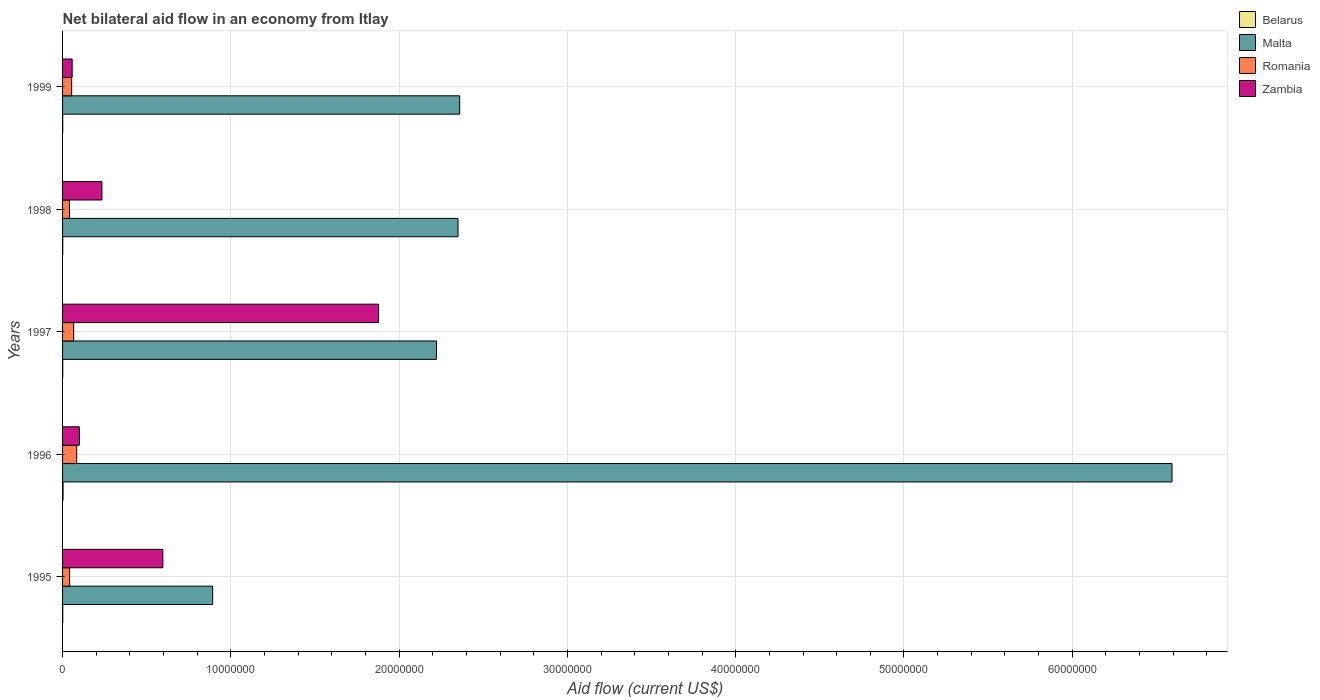How many bars are there on the 1st tick from the top?
Your answer should be very brief. 4. How many bars are there on the 3rd tick from the bottom?
Make the answer very short. 4. What is the label of the 3rd group of bars from the top?
Provide a succinct answer. 1997. What is the net bilateral aid flow in Romania in 1998?
Your answer should be very brief. 4.10e+05. Across all years, what is the maximum net bilateral aid flow in Belarus?
Your answer should be compact. 3.00e+04. Across all years, what is the minimum net bilateral aid flow in Malta?
Offer a terse response. 8.92e+06. In which year was the net bilateral aid flow in Malta maximum?
Make the answer very short. 1996. In which year was the net bilateral aid flow in Zambia minimum?
Your response must be concise. 1999. What is the total net bilateral aid flow in Romania in the graph?
Offer a very short reply. 2.87e+06. What is the difference between the net bilateral aid flow in Belarus in 1998 and the net bilateral aid flow in Malta in 1999?
Your response must be concise. -2.36e+07. What is the average net bilateral aid flow in Belarus per year?
Ensure brevity in your answer.  1.40e+04. In the year 1998, what is the difference between the net bilateral aid flow in Belarus and net bilateral aid flow in Zambia?
Give a very brief answer. -2.33e+06. What is the ratio of the net bilateral aid flow in Romania in 1997 to that in 1999?
Offer a terse response. 1.22. What is the difference between the highest and the second highest net bilateral aid flow in Belarus?
Keep it short and to the point. 2.00e+04. What is the difference between the highest and the lowest net bilateral aid flow in Zambia?
Provide a short and direct response. 1.82e+07. Is the sum of the net bilateral aid flow in Malta in 1995 and 1997 greater than the maximum net bilateral aid flow in Belarus across all years?
Offer a very short reply. Yes. Is it the case that in every year, the sum of the net bilateral aid flow in Malta and net bilateral aid flow in Zambia is greater than the sum of net bilateral aid flow in Romania and net bilateral aid flow in Belarus?
Keep it short and to the point. Yes. What does the 3rd bar from the top in 1997 represents?
Provide a succinct answer. Malta. What does the 4th bar from the bottom in 1997 represents?
Offer a very short reply. Zambia. Does the graph contain any zero values?
Your answer should be compact. No. Does the graph contain grids?
Provide a succinct answer. Yes. How many legend labels are there?
Provide a succinct answer. 4. What is the title of the graph?
Your answer should be compact. Net bilateral aid flow in an economy from Itlay. Does "South Sudan" appear as one of the legend labels in the graph?
Your answer should be very brief. No. What is the Aid flow (current US$) in Belarus in 1995?
Offer a terse response. 10000. What is the Aid flow (current US$) in Malta in 1995?
Your answer should be very brief. 8.92e+06. What is the Aid flow (current US$) of Zambia in 1995?
Your response must be concise. 5.96e+06. What is the Aid flow (current US$) of Belarus in 1996?
Your response must be concise. 3.00e+04. What is the Aid flow (current US$) in Malta in 1996?
Ensure brevity in your answer.  6.59e+07. What is the Aid flow (current US$) in Romania in 1996?
Your response must be concise. 8.40e+05. What is the Aid flow (current US$) in Belarus in 1997?
Your answer should be compact. 10000. What is the Aid flow (current US$) of Malta in 1997?
Give a very brief answer. 2.22e+07. What is the Aid flow (current US$) in Zambia in 1997?
Provide a short and direct response. 1.88e+07. What is the Aid flow (current US$) of Malta in 1998?
Offer a terse response. 2.35e+07. What is the Aid flow (current US$) of Zambia in 1998?
Offer a terse response. 2.34e+06. What is the Aid flow (current US$) in Malta in 1999?
Make the answer very short. 2.36e+07. What is the Aid flow (current US$) in Romania in 1999?
Your answer should be very brief. 5.40e+05. What is the Aid flow (current US$) in Zambia in 1999?
Make the answer very short. 5.70e+05. Across all years, what is the maximum Aid flow (current US$) of Malta?
Your answer should be compact. 6.59e+07. Across all years, what is the maximum Aid flow (current US$) of Romania?
Offer a very short reply. 8.40e+05. Across all years, what is the maximum Aid flow (current US$) in Zambia?
Provide a succinct answer. 1.88e+07. Across all years, what is the minimum Aid flow (current US$) in Belarus?
Your answer should be compact. 10000. Across all years, what is the minimum Aid flow (current US$) in Malta?
Your answer should be very brief. 8.92e+06. Across all years, what is the minimum Aid flow (current US$) of Romania?
Provide a short and direct response. 4.10e+05. Across all years, what is the minimum Aid flow (current US$) of Zambia?
Your answer should be compact. 5.70e+05. What is the total Aid flow (current US$) in Belarus in the graph?
Offer a very short reply. 7.00e+04. What is the total Aid flow (current US$) in Malta in the graph?
Make the answer very short. 1.44e+08. What is the total Aid flow (current US$) in Romania in the graph?
Keep it short and to the point. 2.87e+06. What is the total Aid flow (current US$) of Zambia in the graph?
Ensure brevity in your answer.  2.86e+07. What is the difference between the Aid flow (current US$) of Malta in 1995 and that in 1996?
Give a very brief answer. -5.70e+07. What is the difference between the Aid flow (current US$) in Romania in 1995 and that in 1996?
Your response must be concise. -4.20e+05. What is the difference between the Aid flow (current US$) in Zambia in 1995 and that in 1996?
Your answer should be very brief. 4.96e+06. What is the difference between the Aid flow (current US$) of Malta in 1995 and that in 1997?
Ensure brevity in your answer.  -1.33e+07. What is the difference between the Aid flow (current US$) of Romania in 1995 and that in 1997?
Ensure brevity in your answer.  -2.40e+05. What is the difference between the Aid flow (current US$) of Zambia in 1995 and that in 1997?
Offer a very short reply. -1.28e+07. What is the difference between the Aid flow (current US$) of Belarus in 1995 and that in 1998?
Your answer should be very brief. 0. What is the difference between the Aid flow (current US$) in Malta in 1995 and that in 1998?
Your response must be concise. -1.46e+07. What is the difference between the Aid flow (current US$) of Romania in 1995 and that in 1998?
Give a very brief answer. 10000. What is the difference between the Aid flow (current US$) of Zambia in 1995 and that in 1998?
Keep it short and to the point. 3.62e+06. What is the difference between the Aid flow (current US$) in Belarus in 1995 and that in 1999?
Your answer should be compact. 0. What is the difference between the Aid flow (current US$) of Malta in 1995 and that in 1999?
Make the answer very short. -1.47e+07. What is the difference between the Aid flow (current US$) of Romania in 1995 and that in 1999?
Your answer should be very brief. -1.20e+05. What is the difference between the Aid flow (current US$) of Zambia in 1995 and that in 1999?
Make the answer very short. 5.39e+06. What is the difference between the Aid flow (current US$) in Belarus in 1996 and that in 1997?
Give a very brief answer. 2.00e+04. What is the difference between the Aid flow (current US$) of Malta in 1996 and that in 1997?
Ensure brevity in your answer.  4.37e+07. What is the difference between the Aid flow (current US$) of Romania in 1996 and that in 1997?
Your response must be concise. 1.80e+05. What is the difference between the Aid flow (current US$) in Zambia in 1996 and that in 1997?
Offer a very short reply. -1.78e+07. What is the difference between the Aid flow (current US$) in Malta in 1996 and that in 1998?
Give a very brief answer. 4.24e+07. What is the difference between the Aid flow (current US$) in Romania in 1996 and that in 1998?
Provide a succinct answer. 4.30e+05. What is the difference between the Aid flow (current US$) of Zambia in 1996 and that in 1998?
Provide a succinct answer. -1.34e+06. What is the difference between the Aid flow (current US$) in Belarus in 1996 and that in 1999?
Provide a succinct answer. 2.00e+04. What is the difference between the Aid flow (current US$) in Malta in 1996 and that in 1999?
Your response must be concise. 4.23e+07. What is the difference between the Aid flow (current US$) in Romania in 1996 and that in 1999?
Your response must be concise. 3.00e+05. What is the difference between the Aid flow (current US$) of Malta in 1997 and that in 1998?
Ensure brevity in your answer.  -1.28e+06. What is the difference between the Aid flow (current US$) of Romania in 1997 and that in 1998?
Give a very brief answer. 2.50e+05. What is the difference between the Aid flow (current US$) of Zambia in 1997 and that in 1998?
Ensure brevity in your answer.  1.64e+07. What is the difference between the Aid flow (current US$) of Malta in 1997 and that in 1999?
Your answer should be compact. -1.38e+06. What is the difference between the Aid flow (current US$) of Zambia in 1997 and that in 1999?
Ensure brevity in your answer.  1.82e+07. What is the difference between the Aid flow (current US$) in Belarus in 1998 and that in 1999?
Keep it short and to the point. 0. What is the difference between the Aid flow (current US$) of Malta in 1998 and that in 1999?
Give a very brief answer. -1.00e+05. What is the difference between the Aid flow (current US$) in Zambia in 1998 and that in 1999?
Make the answer very short. 1.77e+06. What is the difference between the Aid flow (current US$) in Belarus in 1995 and the Aid flow (current US$) in Malta in 1996?
Your response must be concise. -6.59e+07. What is the difference between the Aid flow (current US$) in Belarus in 1995 and the Aid flow (current US$) in Romania in 1996?
Provide a succinct answer. -8.30e+05. What is the difference between the Aid flow (current US$) of Belarus in 1995 and the Aid flow (current US$) of Zambia in 1996?
Make the answer very short. -9.90e+05. What is the difference between the Aid flow (current US$) of Malta in 1995 and the Aid flow (current US$) of Romania in 1996?
Your answer should be very brief. 8.08e+06. What is the difference between the Aid flow (current US$) of Malta in 1995 and the Aid flow (current US$) of Zambia in 1996?
Give a very brief answer. 7.92e+06. What is the difference between the Aid flow (current US$) in Romania in 1995 and the Aid flow (current US$) in Zambia in 1996?
Provide a succinct answer. -5.80e+05. What is the difference between the Aid flow (current US$) of Belarus in 1995 and the Aid flow (current US$) of Malta in 1997?
Offer a terse response. -2.22e+07. What is the difference between the Aid flow (current US$) of Belarus in 1995 and the Aid flow (current US$) of Romania in 1997?
Make the answer very short. -6.50e+05. What is the difference between the Aid flow (current US$) of Belarus in 1995 and the Aid flow (current US$) of Zambia in 1997?
Provide a short and direct response. -1.88e+07. What is the difference between the Aid flow (current US$) in Malta in 1995 and the Aid flow (current US$) in Romania in 1997?
Your answer should be compact. 8.26e+06. What is the difference between the Aid flow (current US$) of Malta in 1995 and the Aid flow (current US$) of Zambia in 1997?
Offer a terse response. -9.86e+06. What is the difference between the Aid flow (current US$) in Romania in 1995 and the Aid flow (current US$) in Zambia in 1997?
Provide a succinct answer. -1.84e+07. What is the difference between the Aid flow (current US$) of Belarus in 1995 and the Aid flow (current US$) of Malta in 1998?
Your answer should be compact. -2.35e+07. What is the difference between the Aid flow (current US$) of Belarus in 1995 and the Aid flow (current US$) of Romania in 1998?
Give a very brief answer. -4.00e+05. What is the difference between the Aid flow (current US$) in Belarus in 1995 and the Aid flow (current US$) in Zambia in 1998?
Give a very brief answer. -2.33e+06. What is the difference between the Aid flow (current US$) of Malta in 1995 and the Aid flow (current US$) of Romania in 1998?
Provide a succinct answer. 8.51e+06. What is the difference between the Aid flow (current US$) of Malta in 1995 and the Aid flow (current US$) of Zambia in 1998?
Offer a terse response. 6.58e+06. What is the difference between the Aid flow (current US$) in Romania in 1995 and the Aid flow (current US$) in Zambia in 1998?
Your answer should be very brief. -1.92e+06. What is the difference between the Aid flow (current US$) of Belarus in 1995 and the Aid flow (current US$) of Malta in 1999?
Your response must be concise. -2.36e+07. What is the difference between the Aid flow (current US$) of Belarus in 1995 and the Aid flow (current US$) of Romania in 1999?
Your response must be concise. -5.30e+05. What is the difference between the Aid flow (current US$) of Belarus in 1995 and the Aid flow (current US$) of Zambia in 1999?
Ensure brevity in your answer.  -5.60e+05. What is the difference between the Aid flow (current US$) in Malta in 1995 and the Aid flow (current US$) in Romania in 1999?
Your response must be concise. 8.38e+06. What is the difference between the Aid flow (current US$) in Malta in 1995 and the Aid flow (current US$) in Zambia in 1999?
Your answer should be very brief. 8.35e+06. What is the difference between the Aid flow (current US$) in Belarus in 1996 and the Aid flow (current US$) in Malta in 1997?
Your response must be concise. -2.22e+07. What is the difference between the Aid flow (current US$) in Belarus in 1996 and the Aid flow (current US$) in Romania in 1997?
Make the answer very short. -6.30e+05. What is the difference between the Aid flow (current US$) of Belarus in 1996 and the Aid flow (current US$) of Zambia in 1997?
Give a very brief answer. -1.88e+07. What is the difference between the Aid flow (current US$) of Malta in 1996 and the Aid flow (current US$) of Romania in 1997?
Provide a succinct answer. 6.53e+07. What is the difference between the Aid flow (current US$) in Malta in 1996 and the Aid flow (current US$) in Zambia in 1997?
Give a very brief answer. 4.72e+07. What is the difference between the Aid flow (current US$) of Romania in 1996 and the Aid flow (current US$) of Zambia in 1997?
Keep it short and to the point. -1.79e+07. What is the difference between the Aid flow (current US$) in Belarus in 1996 and the Aid flow (current US$) in Malta in 1998?
Provide a short and direct response. -2.35e+07. What is the difference between the Aid flow (current US$) in Belarus in 1996 and the Aid flow (current US$) in Romania in 1998?
Offer a very short reply. -3.80e+05. What is the difference between the Aid flow (current US$) in Belarus in 1996 and the Aid flow (current US$) in Zambia in 1998?
Your answer should be very brief. -2.31e+06. What is the difference between the Aid flow (current US$) of Malta in 1996 and the Aid flow (current US$) of Romania in 1998?
Give a very brief answer. 6.55e+07. What is the difference between the Aid flow (current US$) of Malta in 1996 and the Aid flow (current US$) of Zambia in 1998?
Provide a succinct answer. 6.36e+07. What is the difference between the Aid flow (current US$) in Romania in 1996 and the Aid flow (current US$) in Zambia in 1998?
Offer a terse response. -1.50e+06. What is the difference between the Aid flow (current US$) of Belarus in 1996 and the Aid flow (current US$) of Malta in 1999?
Your answer should be compact. -2.36e+07. What is the difference between the Aid flow (current US$) of Belarus in 1996 and the Aid flow (current US$) of Romania in 1999?
Give a very brief answer. -5.10e+05. What is the difference between the Aid flow (current US$) of Belarus in 1996 and the Aid flow (current US$) of Zambia in 1999?
Your answer should be very brief. -5.40e+05. What is the difference between the Aid flow (current US$) in Malta in 1996 and the Aid flow (current US$) in Romania in 1999?
Ensure brevity in your answer.  6.54e+07. What is the difference between the Aid flow (current US$) in Malta in 1996 and the Aid flow (current US$) in Zambia in 1999?
Your answer should be very brief. 6.54e+07. What is the difference between the Aid flow (current US$) in Belarus in 1997 and the Aid flow (current US$) in Malta in 1998?
Your response must be concise. -2.35e+07. What is the difference between the Aid flow (current US$) of Belarus in 1997 and the Aid flow (current US$) of Romania in 1998?
Give a very brief answer. -4.00e+05. What is the difference between the Aid flow (current US$) in Belarus in 1997 and the Aid flow (current US$) in Zambia in 1998?
Ensure brevity in your answer.  -2.33e+06. What is the difference between the Aid flow (current US$) in Malta in 1997 and the Aid flow (current US$) in Romania in 1998?
Your answer should be very brief. 2.18e+07. What is the difference between the Aid flow (current US$) of Malta in 1997 and the Aid flow (current US$) of Zambia in 1998?
Offer a very short reply. 1.99e+07. What is the difference between the Aid flow (current US$) of Romania in 1997 and the Aid flow (current US$) of Zambia in 1998?
Give a very brief answer. -1.68e+06. What is the difference between the Aid flow (current US$) of Belarus in 1997 and the Aid flow (current US$) of Malta in 1999?
Your response must be concise. -2.36e+07. What is the difference between the Aid flow (current US$) in Belarus in 1997 and the Aid flow (current US$) in Romania in 1999?
Offer a terse response. -5.30e+05. What is the difference between the Aid flow (current US$) of Belarus in 1997 and the Aid flow (current US$) of Zambia in 1999?
Provide a short and direct response. -5.60e+05. What is the difference between the Aid flow (current US$) in Malta in 1997 and the Aid flow (current US$) in Romania in 1999?
Your answer should be very brief. 2.17e+07. What is the difference between the Aid flow (current US$) of Malta in 1997 and the Aid flow (current US$) of Zambia in 1999?
Offer a very short reply. 2.16e+07. What is the difference between the Aid flow (current US$) in Romania in 1997 and the Aid flow (current US$) in Zambia in 1999?
Offer a terse response. 9.00e+04. What is the difference between the Aid flow (current US$) in Belarus in 1998 and the Aid flow (current US$) in Malta in 1999?
Your answer should be very brief. -2.36e+07. What is the difference between the Aid flow (current US$) of Belarus in 1998 and the Aid flow (current US$) of Romania in 1999?
Give a very brief answer. -5.30e+05. What is the difference between the Aid flow (current US$) of Belarus in 1998 and the Aid flow (current US$) of Zambia in 1999?
Give a very brief answer. -5.60e+05. What is the difference between the Aid flow (current US$) of Malta in 1998 and the Aid flow (current US$) of Romania in 1999?
Provide a succinct answer. 2.30e+07. What is the difference between the Aid flow (current US$) in Malta in 1998 and the Aid flow (current US$) in Zambia in 1999?
Your response must be concise. 2.29e+07. What is the difference between the Aid flow (current US$) in Romania in 1998 and the Aid flow (current US$) in Zambia in 1999?
Your answer should be very brief. -1.60e+05. What is the average Aid flow (current US$) in Belarus per year?
Your answer should be compact. 1.40e+04. What is the average Aid flow (current US$) in Malta per year?
Your answer should be compact. 2.88e+07. What is the average Aid flow (current US$) of Romania per year?
Provide a short and direct response. 5.74e+05. What is the average Aid flow (current US$) of Zambia per year?
Provide a short and direct response. 5.73e+06. In the year 1995, what is the difference between the Aid flow (current US$) of Belarus and Aid flow (current US$) of Malta?
Your answer should be very brief. -8.91e+06. In the year 1995, what is the difference between the Aid flow (current US$) in Belarus and Aid flow (current US$) in Romania?
Your answer should be very brief. -4.10e+05. In the year 1995, what is the difference between the Aid flow (current US$) in Belarus and Aid flow (current US$) in Zambia?
Offer a terse response. -5.95e+06. In the year 1995, what is the difference between the Aid flow (current US$) of Malta and Aid flow (current US$) of Romania?
Your response must be concise. 8.50e+06. In the year 1995, what is the difference between the Aid flow (current US$) of Malta and Aid flow (current US$) of Zambia?
Make the answer very short. 2.96e+06. In the year 1995, what is the difference between the Aid flow (current US$) of Romania and Aid flow (current US$) of Zambia?
Offer a terse response. -5.54e+06. In the year 1996, what is the difference between the Aid flow (current US$) of Belarus and Aid flow (current US$) of Malta?
Provide a short and direct response. -6.59e+07. In the year 1996, what is the difference between the Aid flow (current US$) of Belarus and Aid flow (current US$) of Romania?
Your answer should be compact. -8.10e+05. In the year 1996, what is the difference between the Aid flow (current US$) of Belarus and Aid flow (current US$) of Zambia?
Your response must be concise. -9.70e+05. In the year 1996, what is the difference between the Aid flow (current US$) of Malta and Aid flow (current US$) of Romania?
Make the answer very short. 6.51e+07. In the year 1996, what is the difference between the Aid flow (current US$) in Malta and Aid flow (current US$) in Zambia?
Ensure brevity in your answer.  6.49e+07. In the year 1997, what is the difference between the Aid flow (current US$) of Belarus and Aid flow (current US$) of Malta?
Provide a succinct answer. -2.22e+07. In the year 1997, what is the difference between the Aid flow (current US$) of Belarus and Aid flow (current US$) of Romania?
Offer a very short reply. -6.50e+05. In the year 1997, what is the difference between the Aid flow (current US$) of Belarus and Aid flow (current US$) of Zambia?
Make the answer very short. -1.88e+07. In the year 1997, what is the difference between the Aid flow (current US$) of Malta and Aid flow (current US$) of Romania?
Offer a very short reply. 2.16e+07. In the year 1997, what is the difference between the Aid flow (current US$) of Malta and Aid flow (current US$) of Zambia?
Your answer should be compact. 3.44e+06. In the year 1997, what is the difference between the Aid flow (current US$) of Romania and Aid flow (current US$) of Zambia?
Ensure brevity in your answer.  -1.81e+07. In the year 1998, what is the difference between the Aid flow (current US$) of Belarus and Aid flow (current US$) of Malta?
Offer a very short reply. -2.35e+07. In the year 1998, what is the difference between the Aid flow (current US$) of Belarus and Aid flow (current US$) of Romania?
Provide a succinct answer. -4.00e+05. In the year 1998, what is the difference between the Aid flow (current US$) in Belarus and Aid flow (current US$) in Zambia?
Offer a terse response. -2.33e+06. In the year 1998, what is the difference between the Aid flow (current US$) of Malta and Aid flow (current US$) of Romania?
Provide a short and direct response. 2.31e+07. In the year 1998, what is the difference between the Aid flow (current US$) of Malta and Aid flow (current US$) of Zambia?
Offer a terse response. 2.12e+07. In the year 1998, what is the difference between the Aid flow (current US$) in Romania and Aid flow (current US$) in Zambia?
Offer a very short reply. -1.93e+06. In the year 1999, what is the difference between the Aid flow (current US$) in Belarus and Aid flow (current US$) in Malta?
Make the answer very short. -2.36e+07. In the year 1999, what is the difference between the Aid flow (current US$) of Belarus and Aid flow (current US$) of Romania?
Provide a succinct answer. -5.30e+05. In the year 1999, what is the difference between the Aid flow (current US$) of Belarus and Aid flow (current US$) of Zambia?
Your answer should be very brief. -5.60e+05. In the year 1999, what is the difference between the Aid flow (current US$) in Malta and Aid flow (current US$) in Romania?
Give a very brief answer. 2.31e+07. In the year 1999, what is the difference between the Aid flow (current US$) of Malta and Aid flow (current US$) of Zambia?
Offer a very short reply. 2.30e+07. What is the ratio of the Aid flow (current US$) of Belarus in 1995 to that in 1996?
Provide a short and direct response. 0.33. What is the ratio of the Aid flow (current US$) of Malta in 1995 to that in 1996?
Ensure brevity in your answer.  0.14. What is the ratio of the Aid flow (current US$) in Zambia in 1995 to that in 1996?
Offer a terse response. 5.96. What is the ratio of the Aid flow (current US$) of Malta in 1995 to that in 1997?
Your response must be concise. 0.4. What is the ratio of the Aid flow (current US$) of Romania in 1995 to that in 1997?
Your response must be concise. 0.64. What is the ratio of the Aid flow (current US$) in Zambia in 1995 to that in 1997?
Offer a terse response. 0.32. What is the ratio of the Aid flow (current US$) in Belarus in 1995 to that in 1998?
Offer a very short reply. 1. What is the ratio of the Aid flow (current US$) of Malta in 1995 to that in 1998?
Ensure brevity in your answer.  0.38. What is the ratio of the Aid flow (current US$) of Romania in 1995 to that in 1998?
Give a very brief answer. 1.02. What is the ratio of the Aid flow (current US$) in Zambia in 1995 to that in 1998?
Ensure brevity in your answer.  2.55. What is the ratio of the Aid flow (current US$) of Malta in 1995 to that in 1999?
Give a very brief answer. 0.38. What is the ratio of the Aid flow (current US$) in Zambia in 1995 to that in 1999?
Make the answer very short. 10.46. What is the ratio of the Aid flow (current US$) of Belarus in 1996 to that in 1997?
Your answer should be very brief. 3. What is the ratio of the Aid flow (current US$) in Malta in 1996 to that in 1997?
Make the answer very short. 2.97. What is the ratio of the Aid flow (current US$) of Romania in 1996 to that in 1997?
Provide a succinct answer. 1.27. What is the ratio of the Aid flow (current US$) in Zambia in 1996 to that in 1997?
Keep it short and to the point. 0.05. What is the ratio of the Aid flow (current US$) of Malta in 1996 to that in 1998?
Your response must be concise. 2.81. What is the ratio of the Aid flow (current US$) of Romania in 1996 to that in 1998?
Make the answer very short. 2.05. What is the ratio of the Aid flow (current US$) of Zambia in 1996 to that in 1998?
Your answer should be very brief. 0.43. What is the ratio of the Aid flow (current US$) in Malta in 1996 to that in 1999?
Make the answer very short. 2.79. What is the ratio of the Aid flow (current US$) of Romania in 1996 to that in 1999?
Your answer should be very brief. 1.56. What is the ratio of the Aid flow (current US$) of Zambia in 1996 to that in 1999?
Make the answer very short. 1.75. What is the ratio of the Aid flow (current US$) in Belarus in 1997 to that in 1998?
Keep it short and to the point. 1. What is the ratio of the Aid flow (current US$) of Malta in 1997 to that in 1998?
Your response must be concise. 0.95. What is the ratio of the Aid flow (current US$) in Romania in 1997 to that in 1998?
Ensure brevity in your answer.  1.61. What is the ratio of the Aid flow (current US$) of Zambia in 1997 to that in 1998?
Provide a short and direct response. 8.03. What is the ratio of the Aid flow (current US$) of Malta in 1997 to that in 1999?
Provide a succinct answer. 0.94. What is the ratio of the Aid flow (current US$) in Romania in 1997 to that in 1999?
Your answer should be very brief. 1.22. What is the ratio of the Aid flow (current US$) of Zambia in 1997 to that in 1999?
Offer a very short reply. 32.95. What is the ratio of the Aid flow (current US$) in Romania in 1998 to that in 1999?
Keep it short and to the point. 0.76. What is the ratio of the Aid flow (current US$) of Zambia in 1998 to that in 1999?
Your answer should be compact. 4.11. What is the difference between the highest and the second highest Aid flow (current US$) in Belarus?
Your answer should be compact. 2.00e+04. What is the difference between the highest and the second highest Aid flow (current US$) of Malta?
Your answer should be compact. 4.23e+07. What is the difference between the highest and the second highest Aid flow (current US$) of Romania?
Your answer should be very brief. 1.80e+05. What is the difference between the highest and the second highest Aid flow (current US$) of Zambia?
Your answer should be compact. 1.28e+07. What is the difference between the highest and the lowest Aid flow (current US$) in Belarus?
Your answer should be compact. 2.00e+04. What is the difference between the highest and the lowest Aid flow (current US$) of Malta?
Give a very brief answer. 5.70e+07. What is the difference between the highest and the lowest Aid flow (current US$) in Zambia?
Your answer should be very brief. 1.82e+07. 